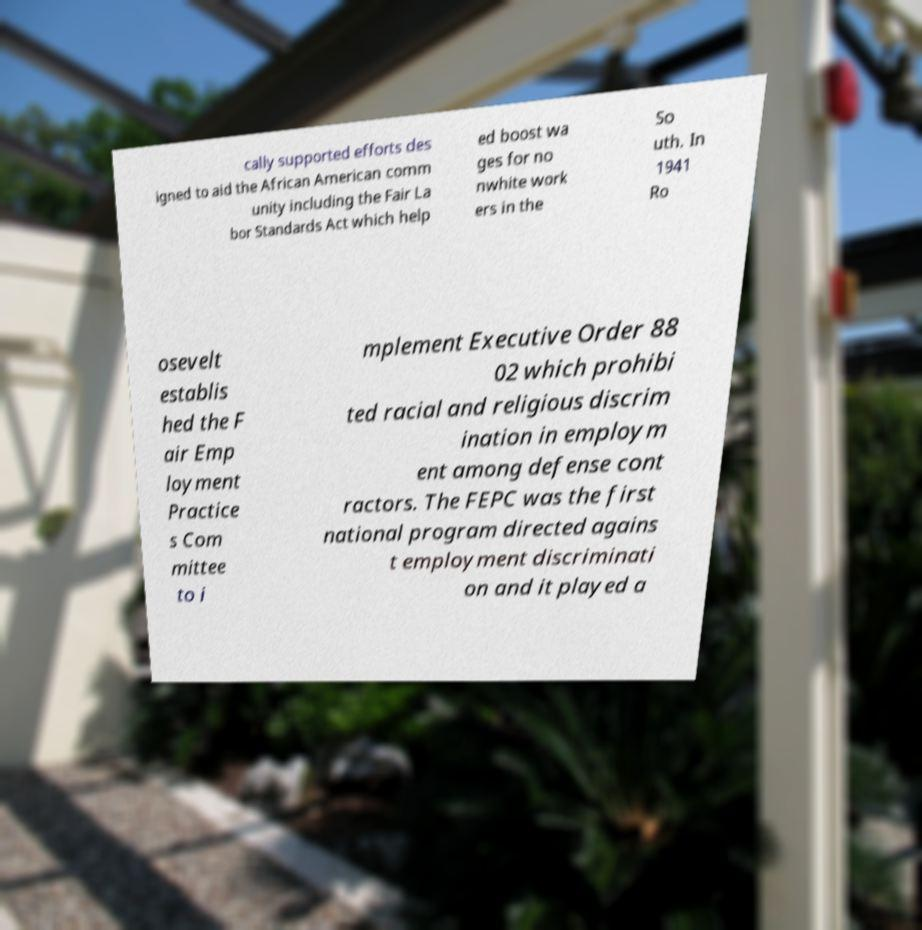Can you accurately transcribe the text from the provided image for me? cally supported efforts des igned to aid the African American comm unity including the Fair La bor Standards Act which help ed boost wa ges for no nwhite work ers in the So uth. In 1941 Ro osevelt establis hed the F air Emp loyment Practice s Com mittee to i mplement Executive Order 88 02 which prohibi ted racial and religious discrim ination in employm ent among defense cont ractors. The FEPC was the first national program directed agains t employment discriminati on and it played a 